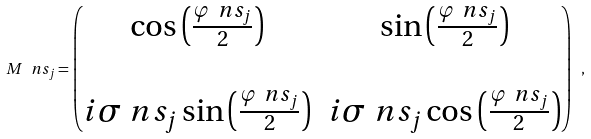Convert formula to latex. <formula><loc_0><loc_0><loc_500><loc_500>M \ n s _ { j } = \begin{pmatrix} \cos \left ( \frac { \varphi \ n s _ { j } } { 2 } \right ) & \sin \left ( \frac { \varphi \ n s _ { j } } { 2 } \right ) \\ & \\ i \sigma \ n s _ { j } \sin \left ( \frac { \varphi \ n s _ { j } } { 2 } \right ) & i \sigma \ n s _ { j } \cos \left ( \frac { \varphi \ n s _ { j } } { 2 } \right ) \end{pmatrix} \ ,</formula> 